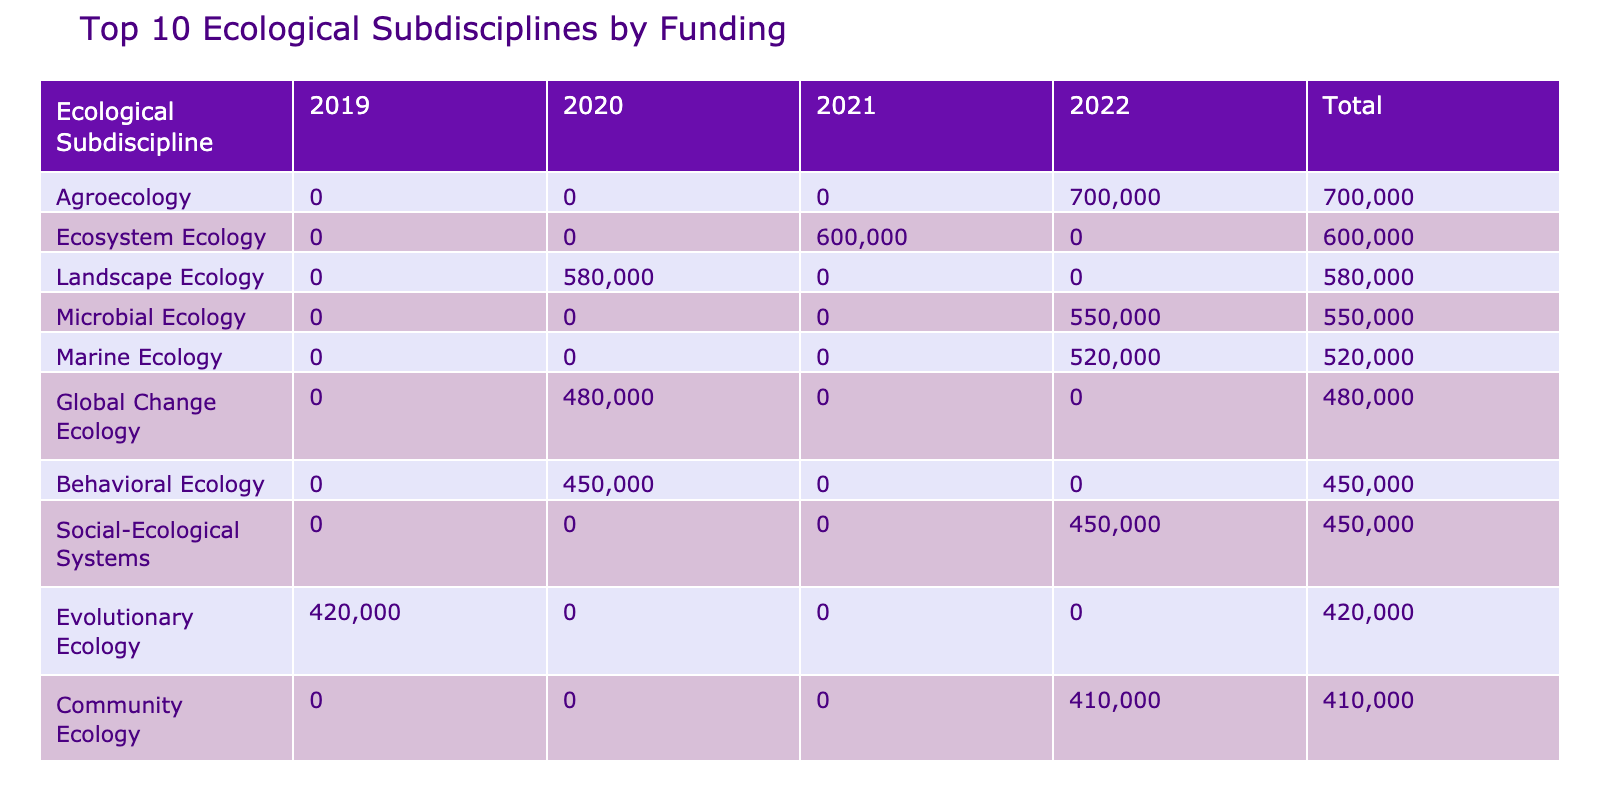What is the total funding allocated to Behavioral Ecology? The total funding for Behavioral Ecology can be found in the table under the row for this subdiscipline. The amount listed for 2020 is 450,000 USD and there are no amounts for other years, so the total is simply this amount.
Answer: 450000 USD Which ecological subdiscipline received funding in the year 2022? To answer this question, we look at the table for the column labeled 2022. The ecological subdisciplines that have values in this column are Marine Ecology (520,000 USD), Microbial Ecology (550,000 USD), Disease Ecology (300,000 USD), Community Ecology (410,000 USD), Agroecology (700,000 USD), and Social-Ecological Systems (450,000 USD).
Answer: Marine Ecology, Microbial Ecology, Disease Ecology, Community Ecology, Agroecology, Social-Ecological Systems What is the average funding amount among the top three subdisciplines by total funding? First, identify the total funding for the top three subdisciplines from the table: Agroecology (700,000 USD), Marine Ecology (520,000 USD), and Microbial Ecology (550,000 USD). The total funding is 700,000 + 520,000 + 550,000 = 1,770,000 USD. There are 3 subdisciplines, so the average is 1,770,000 / 3 = 590,000 USD.
Answer: 590000 USD Did any funding source allocate money to Social-Ecological Systems in 2022? Checking the table, we can find Social-Ecological Systems listed with 450,000 USD allocated in the year 2022. This confirms that there was indeed funding allocated for this subdiscipline in that year.
Answer: Yes What is the difference in funding between the highest and lowest funded ecological subdiscipline? From the table, Agroecology received the highest funding at 700,000 USD, while Conservation Biology received the lowest funding at 75,000 USD. To find the difference, we subtract 75,000 from 700,000: 700,000 - 75,000 = 625,000 USD.
Answer: 625000 USD How much total funding was allocated to Marine-related ecological subdisciplines across all years? We need to examine all entries in the table related to Marine ecological subdisciplines. The funding sources are Marine Ecology (520,000 USD in 2022) and Marine Mammal Ecology (340,000 USD in 2019). Adding these together gives us 520,000 + 340,000 = 860,000 USD.
Answer: 860000 USD Which funding source allocated the largest amount overall and to which ecological subdiscipline? Looking through the table, Agroecology received the largest funding allocation of 700,000 USD from the Bill & Melinda Gates Foundation. This is the only instance at that funding level related to this funding source.
Answer: Bill & Melinda Gates Foundation, Agroecology Are there any ecological subdisciplines that received funding in more than one year? We check each ecological subdiscipline's funding across different years per the table. Only Behavioral Ecology received funding solely in 2020, while others like Community Ecology had funding in 2022. Thus, there are no subdisciplines that received funding in multiple years.
Answer: No 